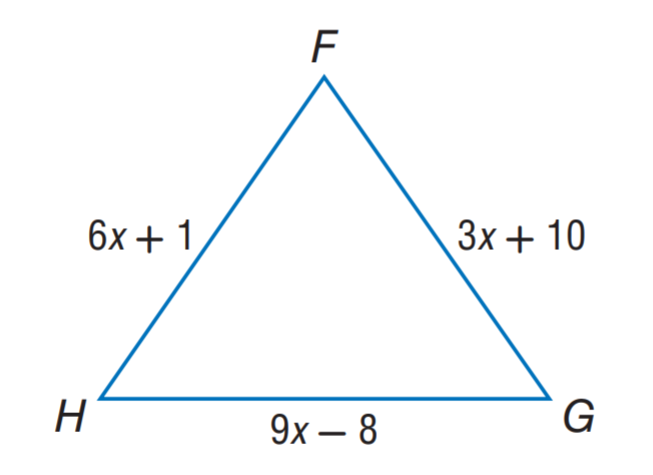Question: \triangle F G H is an equilateral triangle. Find H G.
Choices:
A. 3
B. 16
C. 19
D. 22
Answer with the letter. Answer: C Question: \triangle F G H is an equilateral triangle. Find F G.
Choices:
A. 3
B. 16
C. 19
D. 22
Answer with the letter. Answer: C 